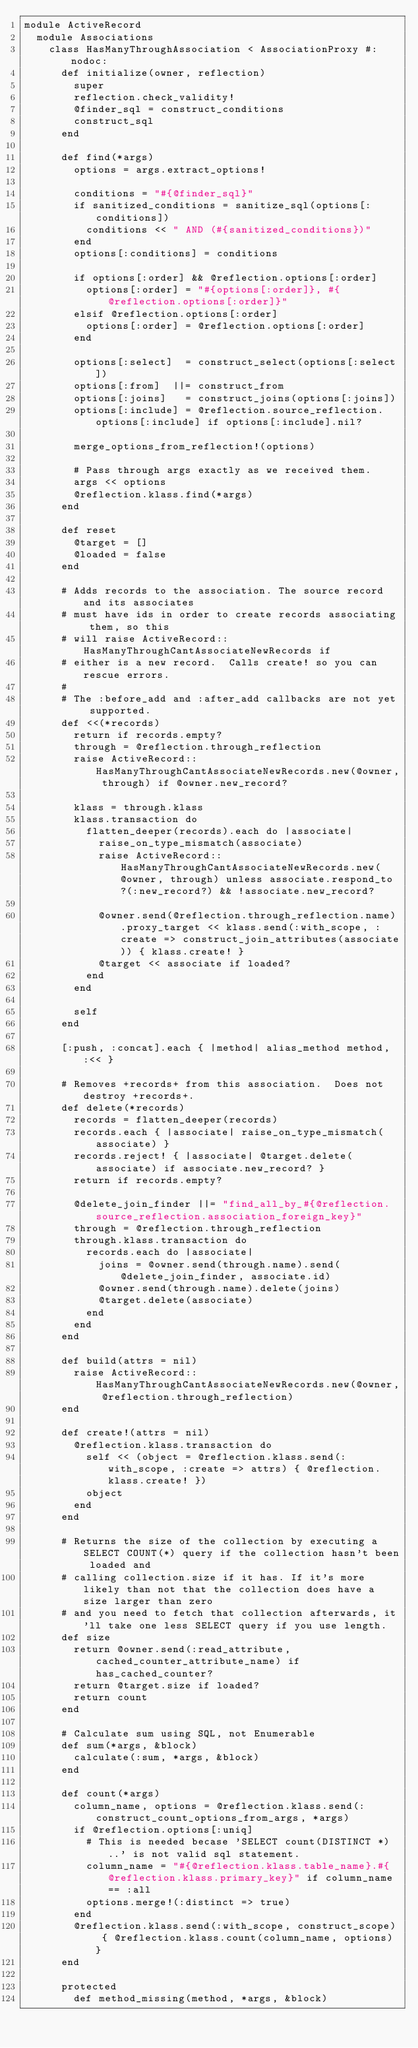<code> <loc_0><loc_0><loc_500><loc_500><_Ruby_>module ActiveRecord
  module Associations
    class HasManyThroughAssociation < AssociationProxy #:nodoc:
      def initialize(owner, reflection)
        super
        reflection.check_validity!
        @finder_sql = construct_conditions
        construct_sql
      end

      def find(*args)
        options = args.extract_options!

        conditions = "#{@finder_sql}"
        if sanitized_conditions = sanitize_sql(options[:conditions])
          conditions << " AND (#{sanitized_conditions})"
        end
        options[:conditions] = conditions

        if options[:order] && @reflection.options[:order]
          options[:order] = "#{options[:order]}, #{@reflection.options[:order]}"
        elsif @reflection.options[:order]
          options[:order] = @reflection.options[:order]
        end

        options[:select]  = construct_select(options[:select])
        options[:from]  ||= construct_from
        options[:joins]   = construct_joins(options[:joins])
        options[:include] = @reflection.source_reflection.options[:include] if options[:include].nil?

        merge_options_from_reflection!(options)

        # Pass through args exactly as we received them.
        args << options
        @reflection.klass.find(*args)
      end

      def reset
        @target = []
        @loaded = false
      end

      # Adds records to the association. The source record and its associates
      # must have ids in order to create records associating them, so this
      # will raise ActiveRecord::HasManyThroughCantAssociateNewRecords if
      # either is a new record.  Calls create! so you can rescue errors.
      #
      # The :before_add and :after_add callbacks are not yet supported.
      def <<(*records)
        return if records.empty?
        through = @reflection.through_reflection
        raise ActiveRecord::HasManyThroughCantAssociateNewRecords.new(@owner, through) if @owner.new_record?

        klass = through.klass
        klass.transaction do
          flatten_deeper(records).each do |associate|
            raise_on_type_mismatch(associate)
            raise ActiveRecord::HasManyThroughCantAssociateNewRecords.new(@owner, through) unless associate.respond_to?(:new_record?) && !associate.new_record?

            @owner.send(@reflection.through_reflection.name).proxy_target << klass.send(:with_scope, :create => construct_join_attributes(associate)) { klass.create! }
            @target << associate if loaded?
          end
        end

        self
      end

      [:push, :concat].each { |method| alias_method method, :<< }

      # Removes +records+ from this association.  Does not destroy +records+.
      def delete(*records)
        records = flatten_deeper(records)
        records.each { |associate| raise_on_type_mismatch(associate) }
        records.reject! { |associate| @target.delete(associate) if associate.new_record? }
        return if records.empty?
        
        @delete_join_finder ||= "find_all_by_#{@reflection.source_reflection.association_foreign_key}"
        through = @reflection.through_reflection
        through.klass.transaction do
          records.each do |associate|
            joins = @owner.send(through.name).send(@delete_join_finder, associate.id)
            @owner.send(through.name).delete(joins)
            @target.delete(associate)
          end
        end
      end

      def build(attrs = nil)
        raise ActiveRecord::HasManyThroughCantAssociateNewRecords.new(@owner, @reflection.through_reflection)
      end

      def create!(attrs = nil)
        @reflection.klass.transaction do
          self << (object = @reflection.klass.send(:with_scope, :create => attrs) { @reflection.klass.create! })
          object
        end
      end

      # Returns the size of the collection by executing a SELECT COUNT(*) query if the collection hasn't been loaded and
      # calling collection.size if it has. If it's more likely than not that the collection does have a size larger than zero
      # and you need to fetch that collection afterwards, it'll take one less SELECT query if you use length.
      def size
        return @owner.send(:read_attribute, cached_counter_attribute_name) if has_cached_counter?
        return @target.size if loaded?
        return count
      end

      # Calculate sum using SQL, not Enumerable
      def sum(*args, &block)
        calculate(:sum, *args, &block)
      end
      
      def count(*args)
        column_name, options = @reflection.klass.send(:construct_count_options_from_args, *args)
        if @reflection.options[:uniq]
          # This is needed becase 'SELECT count(DISTINCT *)..' is not valid sql statement.
          column_name = "#{@reflection.klass.table_name}.#{@reflection.klass.primary_key}" if column_name == :all
          options.merge!(:distinct => true) 
        end
        @reflection.klass.send(:with_scope, construct_scope) { @reflection.klass.count(column_name, options) } 
      end

      protected
        def method_missing(method, *args, &block)</code> 